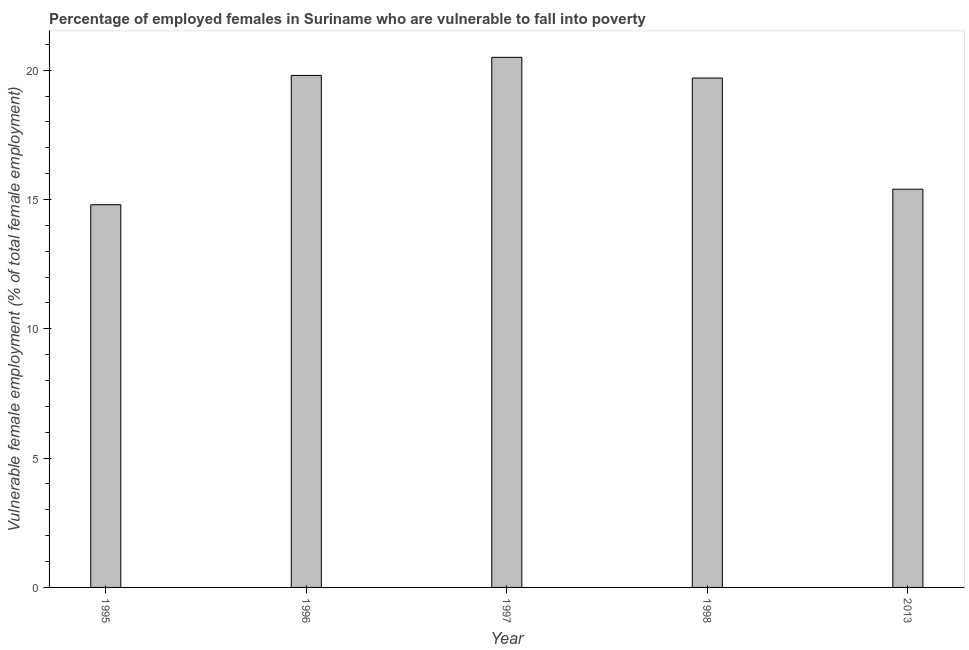Does the graph contain any zero values?
Offer a very short reply. No. Does the graph contain grids?
Your response must be concise. No. What is the title of the graph?
Your answer should be very brief. Percentage of employed females in Suriname who are vulnerable to fall into poverty. What is the label or title of the X-axis?
Provide a short and direct response. Year. What is the label or title of the Y-axis?
Your answer should be very brief. Vulnerable female employment (% of total female employment). What is the percentage of employed females who are vulnerable to fall into poverty in 1996?
Ensure brevity in your answer.  19.8. Across all years, what is the maximum percentage of employed females who are vulnerable to fall into poverty?
Your answer should be very brief. 20.5. Across all years, what is the minimum percentage of employed females who are vulnerable to fall into poverty?
Your answer should be very brief. 14.8. What is the sum of the percentage of employed females who are vulnerable to fall into poverty?
Provide a short and direct response. 90.2. What is the difference between the percentage of employed females who are vulnerable to fall into poverty in 1996 and 1997?
Your answer should be compact. -0.7. What is the average percentage of employed females who are vulnerable to fall into poverty per year?
Provide a succinct answer. 18.04. What is the median percentage of employed females who are vulnerable to fall into poverty?
Keep it short and to the point. 19.7. In how many years, is the percentage of employed females who are vulnerable to fall into poverty greater than 12 %?
Your answer should be very brief. 5. What is the ratio of the percentage of employed females who are vulnerable to fall into poverty in 1997 to that in 2013?
Make the answer very short. 1.33. Is the percentage of employed females who are vulnerable to fall into poverty in 1998 less than that in 2013?
Make the answer very short. No. Is the difference between the percentage of employed females who are vulnerable to fall into poverty in 1995 and 1996 greater than the difference between any two years?
Your answer should be compact. No. What is the difference between the highest and the second highest percentage of employed females who are vulnerable to fall into poverty?
Your answer should be very brief. 0.7. In how many years, is the percentage of employed females who are vulnerable to fall into poverty greater than the average percentage of employed females who are vulnerable to fall into poverty taken over all years?
Provide a succinct answer. 3. Are all the bars in the graph horizontal?
Your answer should be compact. No. How many years are there in the graph?
Keep it short and to the point. 5. What is the Vulnerable female employment (% of total female employment) in 1995?
Your answer should be very brief. 14.8. What is the Vulnerable female employment (% of total female employment) in 1996?
Offer a terse response. 19.8. What is the Vulnerable female employment (% of total female employment) of 1998?
Your response must be concise. 19.7. What is the Vulnerable female employment (% of total female employment) in 2013?
Give a very brief answer. 15.4. What is the difference between the Vulnerable female employment (% of total female employment) in 1995 and 1996?
Offer a very short reply. -5. What is the difference between the Vulnerable female employment (% of total female employment) in 1995 and 1998?
Your answer should be very brief. -4.9. What is the difference between the Vulnerable female employment (% of total female employment) in 1995 and 2013?
Your answer should be compact. -0.6. What is the difference between the Vulnerable female employment (% of total female employment) in 1996 and 1998?
Provide a succinct answer. 0.1. What is the difference between the Vulnerable female employment (% of total female employment) in 1997 and 1998?
Keep it short and to the point. 0.8. What is the ratio of the Vulnerable female employment (% of total female employment) in 1995 to that in 1996?
Keep it short and to the point. 0.75. What is the ratio of the Vulnerable female employment (% of total female employment) in 1995 to that in 1997?
Your response must be concise. 0.72. What is the ratio of the Vulnerable female employment (% of total female employment) in 1995 to that in 1998?
Make the answer very short. 0.75. What is the ratio of the Vulnerable female employment (% of total female employment) in 1996 to that in 2013?
Provide a short and direct response. 1.29. What is the ratio of the Vulnerable female employment (% of total female employment) in 1997 to that in 1998?
Provide a succinct answer. 1.04. What is the ratio of the Vulnerable female employment (% of total female employment) in 1997 to that in 2013?
Offer a terse response. 1.33. What is the ratio of the Vulnerable female employment (% of total female employment) in 1998 to that in 2013?
Give a very brief answer. 1.28. 